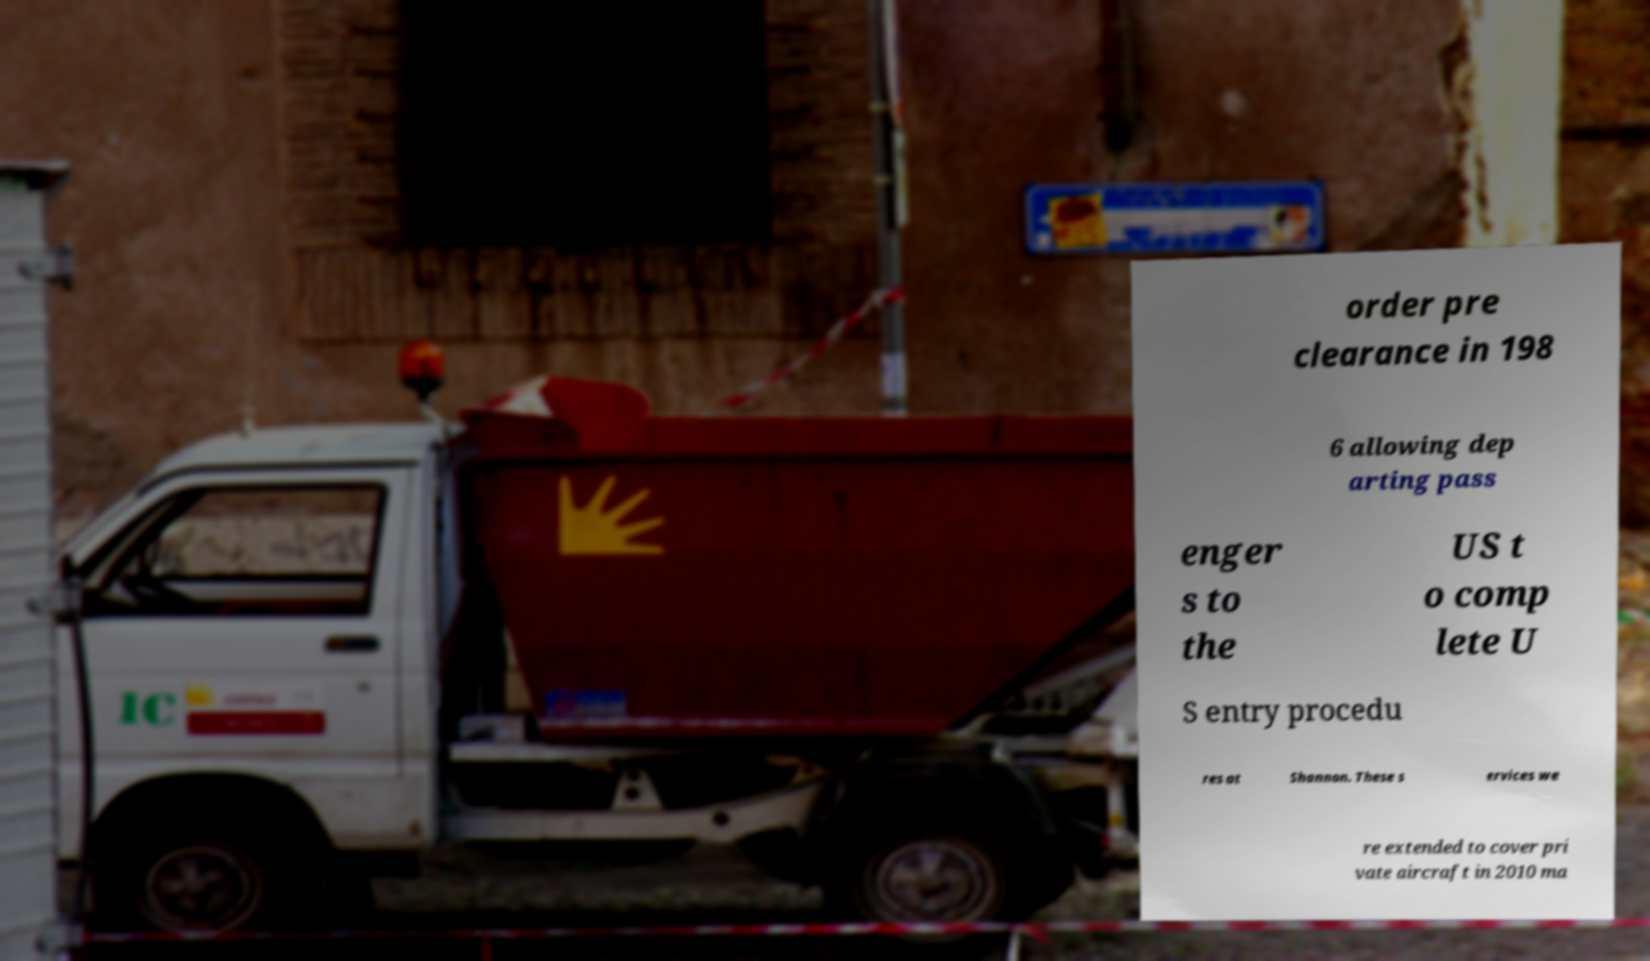I need the written content from this picture converted into text. Can you do that? order pre clearance in 198 6 allowing dep arting pass enger s to the US t o comp lete U S entry procedu res at Shannon. These s ervices we re extended to cover pri vate aircraft in 2010 ma 